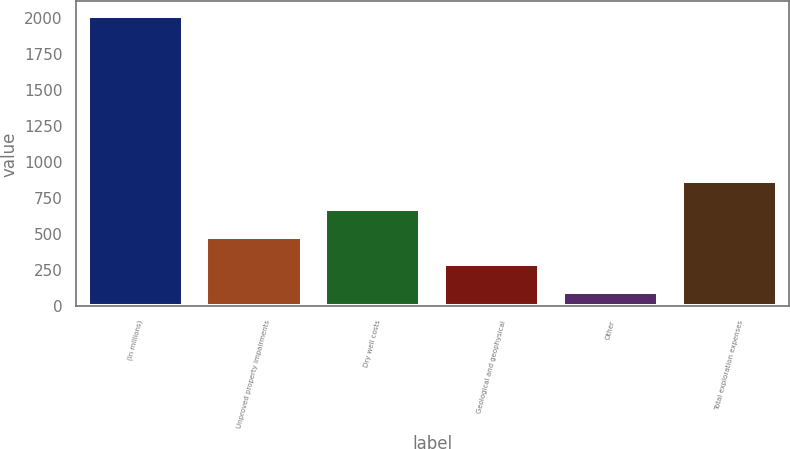Convert chart. <chart><loc_0><loc_0><loc_500><loc_500><bar_chart><fcel>(In millions)<fcel>Unproved property impairments<fcel>Dry well costs<fcel>Geological and geophysical<fcel>Other<fcel>Total exploration expenses<nl><fcel>2012<fcel>483.2<fcel>674.3<fcel>292.1<fcel>101<fcel>865.4<nl></chart> 